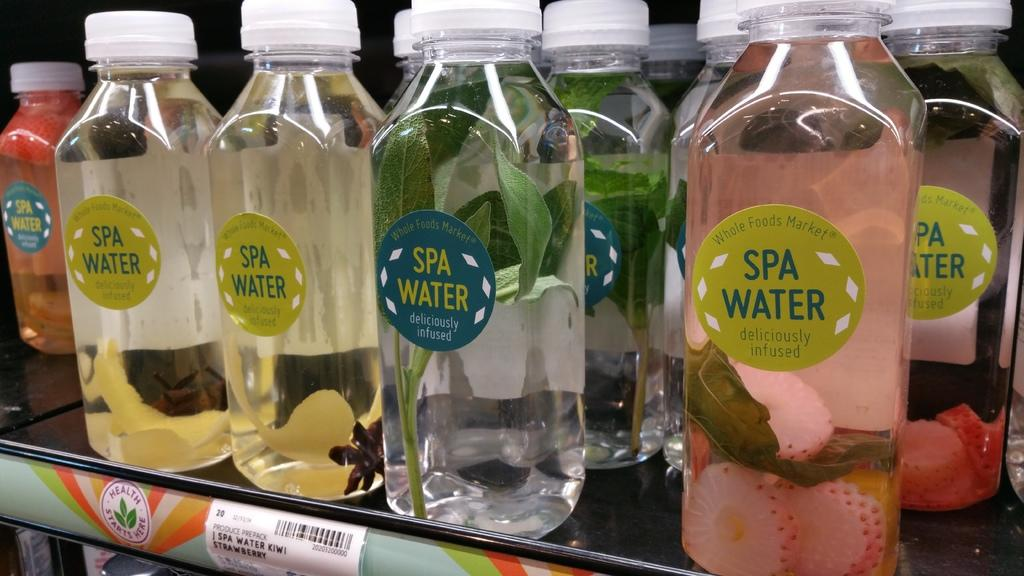Provide a one-sentence caption for the provided image. A bunch of different flavors of Spa Water on a shelve in a store. 